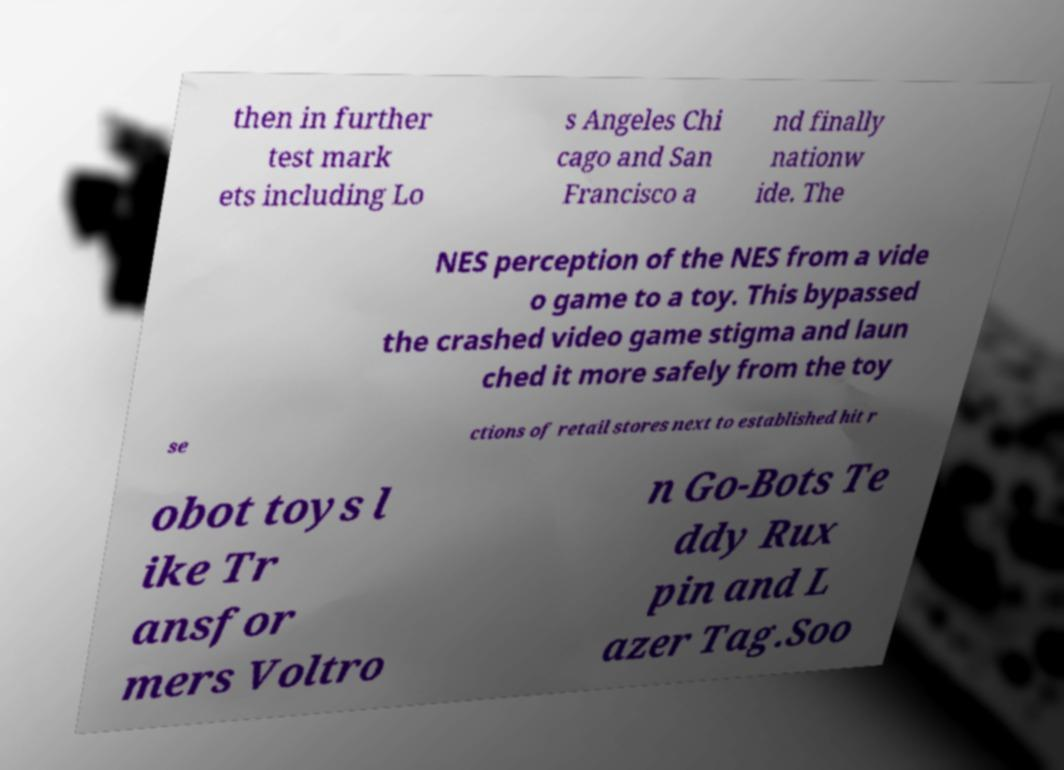Can you read and provide the text displayed in the image?This photo seems to have some interesting text. Can you extract and type it out for me? then in further test mark ets including Lo s Angeles Chi cago and San Francisco a nd finally nationw ide. The NES perception of the NES from a vide o game to a toy. This bypassed the crashed video game stigma and laun ched it more safely from the toy se ctions of retail stores next to established hit r obot toys l ike Tr ansfor mers Voltro n Go-Bots Te ddy Rux pin and L azer Tag.Soo 